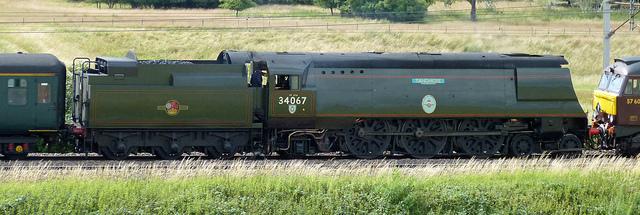What color is the train?
Be succinct. Green. What kind of vehicle is this?
Answer briefly. Train. What color is the grass?
Quick response, please. Green. 